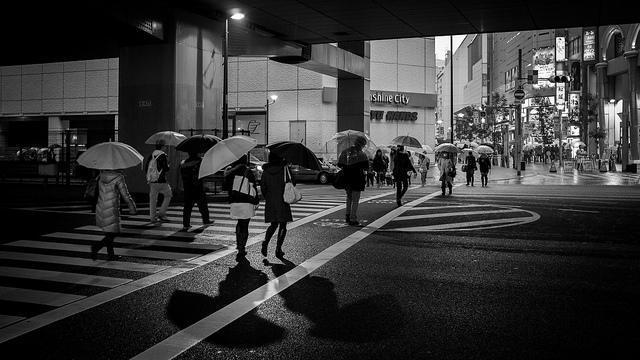How many lights are on in the tunnel?
Give a very brief answer. 2. How many people are there?
Give a very brief answer. 4. 